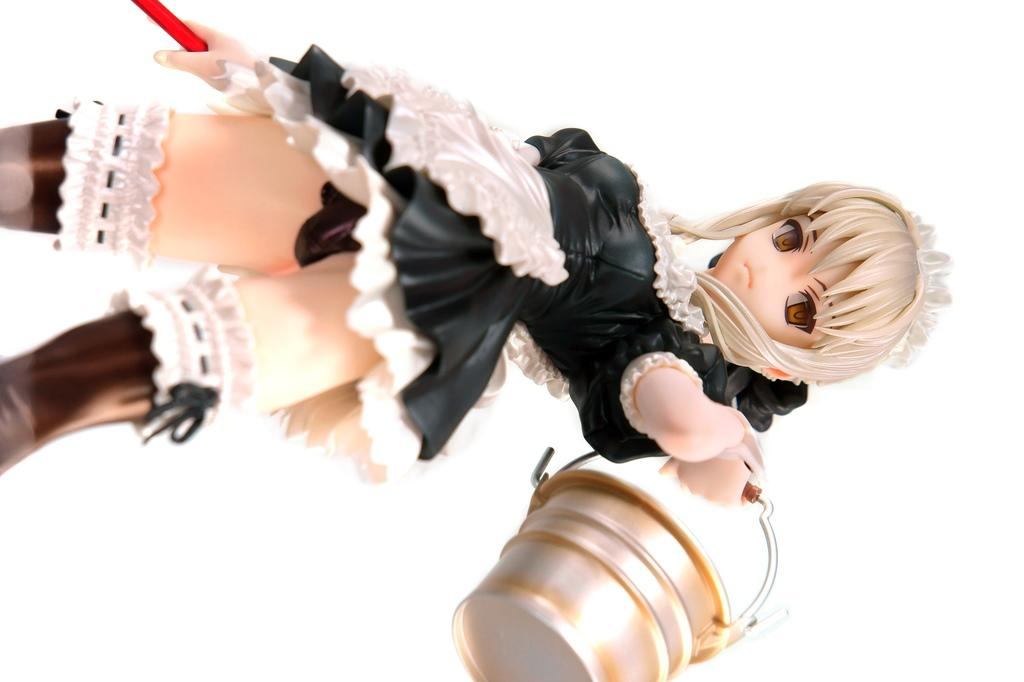What is the main subject in the image? There is a doll in the image. What object is located at the bottom of the image? There is a bucket at the bottom of the image. What color is the background of the image? The background of the image is white. How many snakes are slithering around the doll in the image? There are no snakes present in the image. 